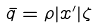<formula> <loc_0><loc_0><loc_500><loc_500>\bar { q } = \rho | x ^ { \prime } | \zeta</formula> 